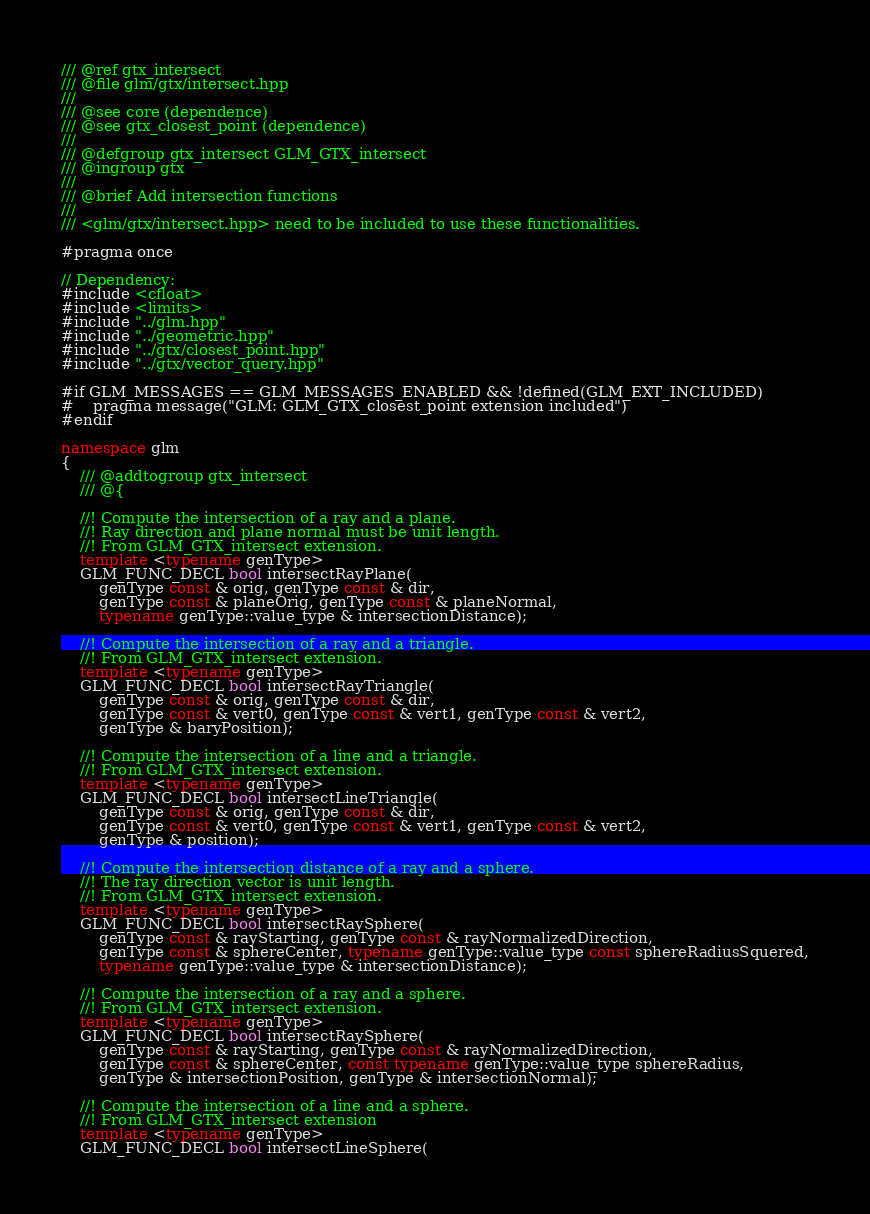<code> <loc_0><loc_0><loc_500><loc_500><_C++_>/// @ref gtx_intersect
/// @file glm/gtx/intersect.hpp
///
/// @see core (dependence)
/// @see gtx_closest_point (dependence)
///
/// @defgroup gtx_intersect GLM_GTX_intersect
/// @ingroup gtx
///
/// @brief Add intersection functions
///
/// <glm/gtx/intersect.hpp> need to be included to use these functionalities.

#pragma once

// Dependency:
#include <cfloat>
#include <limits>
#include "../glm.hpp"
#include "../geometric.hpp"
#include "../gtx/closest_point.hpp"
#include "../gtx/vector_query.hpp"

#if GLM_MESSAGES == GLM_MESSAGES_ENABLED && !defined(GLM_EXT_INCLUDED)
#	pragma message("GLM: GLM_GTX_closest_point extension included")
#endif

namespace glm
{
	/// @addtogroup gtx_intersect
	/// @{

	//! Compute the intersection of a ray and a plane.
	//! Ray direction and plane normal must be unit length.
	//! From GLM_GTX_intersect extension.
	template <typename genType>
	GLM_FUNC_DECL bool intersectRayPlane(
		genType const & orig, genType const & dir,
		genType const & planeOrig, genType const & planeNormal,
		typename genType::value_type & intersectionDistance);

	//! Compute the intersection of a ray and a triangle.
	//! From GLM_GTX_intersect extension.
	template <typename genType>
	GLM_FUNC_DECL bool intersectRayTriangle(
		genType const & orig, genType const & dir,
		genType const & vert0, genType const & vert1, genType const & vert2,
		genType & baryPosition);

	//! Compute the intersection of a line and a triangle.
	//! From GLM_GTX_intersect extension.
	template <typename genType>
	GLM_FUNC_DECL bool intersectLineTriangle(
		genType const & orig, genType const & dir,
		genType const & vert0, genType const & vert1, genType const & vert2,
		genType & position);

	//! Compute the intersection distance of a ray and a sphere. 
	//! The ray direction vector is unit length.
	//! From GLM_GTX_intersect extension.
	template <typename genType>
	GLM_FUNC_DECL bool intersectRaySphere(
		genType const & rayStarting, genType const & rayNormalizedDirection,
		genType const & sphereCenter, typename genType::value_type const sphereRadiusSquered,
		typename genType::value_type & intersectionDistance);

	//! Compute the intersection of a ray and a sphere.
	//! From GLM_GTX_intersect extension.
	template <typename genType>
	GLM_FUNC_DECL bool intersectRaySphere(
		genType const & rayStarting, genType const & rayNormalizedDirection,
		genType const & sphereCenter, const typename genType::value_type sphereRadius,
		genType & intersectionPosition, genType & intersectionNormal);

	//! Compute the intersection of a line and a sphere.
	//! From GLM_GTX_intersect extension
	template <typename genType>
	GLM_FUNC_DECL bool intersectLineSphere(</code> 